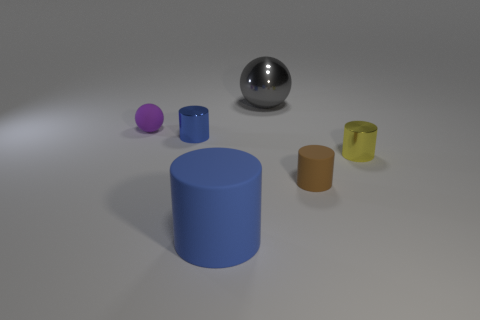There is a large object in front of the small purple matte ball; what is its material?
Offer a very short reply. Rubber. Do the small blue object that is behind the big blue thing and the large gray ball have the same material?
Keep it short and to the point. Yes. Are there any large brown things?
Ensure brevity in your answer.  No. There is a big object that is the same material as the tiny sphere; what color is it?
Give a very brief answer. Blue. There is a large sphere that is on the right side of the rubber cylinder to the left of the rubber cylinder to the right of the large matte thing; what is its color?
Provide a succinct answer. Gray. There is a yellow metallic cylinder; does it have the same size as the sphere on the right side of the purple rubber ball?
Offer a terse response. No. What number of things are either cylinders that are in front of the blue shiny object or small matte things right of the small purple matte object?
Make the answer very short. 3. What shape is the blue metallic object that is the same size as the purple matte ball?
Give a very brief answer. Cylinder. The rubber object to the right of the ball that is behind the small matte object left of the blue matte cylinder is what shape?
Offer a very short reply. Cylinder. Are there the same number of tiny yellow things on the left side of the brown matte thing and small blue things?
Ensure brevity in your answer.  No. 